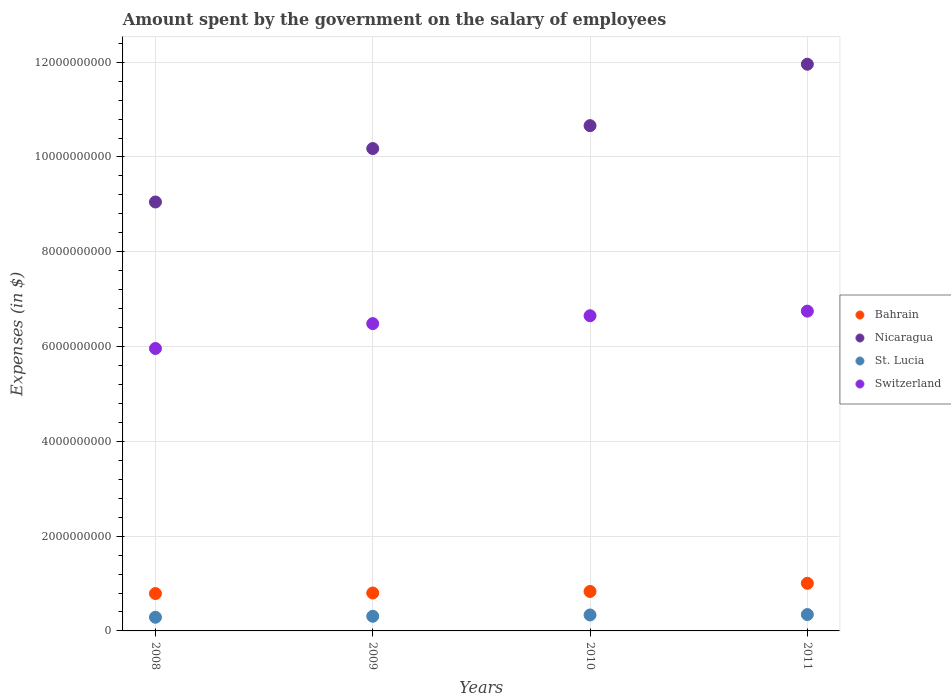How many different coloured dotlines are there?
Your answer should be compact. 4. Is the number of dotlines equal to the number of legend labels?
Offer a terse response. Yes. What is the amount spent on the salary of employees by the government in Bahrain in 2009?
Offer a terse response. 8.00e+08. Across all years, what is the maximum amount spent on the salary of employees by the government in Nicaragua?
Provide a short and direct response. 1.20e+1. Across all years, what is the minimum amount spent on the salary of employees by the government in St. Lucia?
Ensure brevity in your answer.  2.88e+08. In which year was the amount spent on the salary of employees by the government in Switzerland maximum?
Provide a short and direct response. 2011. What is the total amount spent on the salary of employees by the government in Nicaragua in the graph?
Give a very brief answer. 4.18e+1. What is the difference between the amount spent on the salary of employees by the government in Bahrain in 2010 and that in 2011?
Your answer should be compact. -1.73e+08. What is the difference between the amount spent on the salary of employees by the government in St. Lucia in 2011 and the amount spent on the salary of employees by the government in Switzerland in 2008?
Ensure brevity in your answer.  -5.61e+09. What is the average amount spent on the salary of employees by the government in St. Lucia per year?
Offer a terse response. 3.20e+08. In the year 2008, what is the difference between the amount spent on the salary of employees by the government in St. Lucia and amount spent on the salary of employees by the government in Bahrain?
Provide a succinct answer. -5.00e+08. In how many years, is the amount spent on the salary of employees by the government in Nicaragua greater than 9600000000 $?
Keep it short and to the point. 3. What is the ratio of the amount spent on the salary of employees by the government in Switzerland in 2008 to that in 2010?
Your answer should be compact. 0.9. What is the difference between the highest and the second highest amount spent on the salary of employees by the government in Nicaragua?
Offer a very short reply. 1.30e+09. What is the difference between the highest and the lowest amount spent on the salary of employees by the government in Nicaragua?
Give a very brief answer. 2.91e+09. Is the amount spent on the salary of employees by the government in Switzerland strictly greater than the amount spent on the salary of employees by the government in St. Lucia over the years?
Ensure brevity in your answer.  Yes. Is the amount spent on the salary of employees by the government in Bahrain strictly less than the amount spent on the salary of employees by the government in Nicaragua over the years?
Offer a very short reply. Yes. Does the graph contain grids?
Offer a very short reply. Yes. What is the title of the graph?
Provide a short and direct response. Amount spent by the government on the salary of employees. Does "Caribbean small states" appear as one of the legend labels in the graph?
Your response must be concise. No. What is the label or title of the X-axis?
Provide a short and direct response. Years. What is the label or title of the Y-axis?
Your answer should be very brief. Expenses (in $). What is the Expenses (in $) in Bahrain in 2008?
Your response must be concise. 7.89e+08. What is the Expenses (in $) of Nicaragua in 2008?
Offer a very short reply. 9.05e+09. What is the Expenses (in $) of St. Lucia in 2008?
Provide a succinct answer. 2.88e+08. What is the Expenses (in $) in Switzerland in 2008?
Offer a terse response. 5.96e+09. What is the Expenses (in $) of Bahrain in 2009?
Keep it short and to the point. 8.00e+08. What is the Expenses (in $) of Nicaragua in 2009?
Provide a succinct answer. 1.02e+1. What is the Expenses (in $) in St. Lucia in 2009?
Ensure brevity in your answer.  3.09e+08. What is the Expenses (in $) of Switzerland in 2009?
Provide a succinct answer. 6.48e+09. What is the Expenses (in $) of Bahrain in 2010?
Give a very brief answer. 8.32e+08. What is the Expenses (in $) in Nicaragua in 2010?
Offer a terse response. 1.07e+1. What is the Expenses (in $) of St. Lucia in 2010?
Offer a very short reply. 3.37e+08. What is the Expenses (in $) of Switzerland in 2010?
Your answer should be very brief. 6.65e+09. What is the Expenses (in $) in Bahrain in 2011?
Keep it short and to the point. 1.00e+09. What is the Expenses (in $) in Nicaragua in 2011?
Provide a short and direct response. 1.20e+1. What is the Expenses (in $) in St. Lucia in 2011?
Offer a very short reply. 3.45e+08. What is the Expenses (in $) in Switzerland in 2011?
Your answer should be compact. 6.75e+09. Across all years, what is the maximum Expenses (in $) in Bahrain?
Your response must be concise. 1.00e+09. Across all years, what is the maximum Expenses (in $) in Nicaragua?
Give a very brief answer. 1.20e+1. Across all years, what is the maximum Expenses (in $) of St. Lucia?
Give a very brief answer. 3.45e+08. Across all years, what is the maximum Expenses (in $) in Switzerland?
Offer a very short reply. 6.75e+09. Across all years, what is the minimum Expenses (in $) in Bahrain?
Offer a terse response. 7.89e+08. Across all years, what is the minimum Expenses (in $) in Nicaragua?
Your response must be concise. 9.05e+09. Across all years, what is the minimum Expenses (in $) in St. Lucia?
Provide a short and direct response. 2.88e+08. Across all years, what is the minimum Expenses (in $) of Switzerland?
Ensure brevity in your answer.  5.96e+09. What is the total Expenses (in $) in Bahrain in the graph?
Your response must be concise. 3.43e+09. What is the total Expenses (in $) in Nicaragua in the graph?
Provide a short and direct response. 4.18e+1. What is the total Expenses (in $) in St. Lucia in the graph?
Your answer should be compact. 1.28e+09. What is the total Expenses (in $) of Switzerland in the graph?
Offer a terse response. 2.58e+1. What is the difference between the Expenses (in $) in Bahrain in 2008 and that in 2009?
Provide a succinct answer. -1.12e+07. What is the difference between the Expenses (in $) of Nicaragua in 2008 and that in 2009?
Your answer should be compact. -1.13e+09. What is the difference between the Expenses (in $) in St. Lucia in 2008 and that in 2009?
Give a very brief answer. -2.07e+07. What is the difference between the Expenses (in $) in Switzerland in 2008 and that in 2009?
Your answer should be very brief. -5.24e+08. What is the difference between the Expenses (in $) in Bahrain in 2008 and that in 2010?
Provide a short and direct response. -4.38e+07. What is the difference between the Expenses (in $) in Nicaragua in 2008 and that in 2010?
Offer a terse response. -1.61e+09. What is the difference between the Expenses (in $) of St. Lucia in 2008 and that in 2010?
Your answer should be very brief. -4.83e+07. What is the difference between the Expenses (in $) of Switzerland in 2008 and that in 2010?
Ensure brevity in your answer.  -6.91e+08. What is the difference between the Expenses (in $) of Bahrain in 2008 and that in 2011?
Make the answer very short. -2.16e+08. What is the difference between the Expenses (in $) in Nicaragua in 2008 and that in 2011?
Make the answer very short. -2.91e+09. What is the difference between the Expenses (in $) of St. Lucia in 2008 and that in 2011?
Your answer should be very brief. -5.71e+07. What is the difference between the Expenses (in $) of Switzerland in 2008 and that in 2011?
Make the answer very short. -7.88e+08. What is the difference between the Expenses (in $) in Bahrain in 2009 and that in 2010?
Your answer should be very brief. -3.25e+07. What is the difference between the Expenses (in $) of Nicaragua in 2009 and that in 2010?
Offer a very short reply. -4.83e+08. What is the difference between the Expenses (in $) in St. Lucia in 2009 and that in 2010?
Keep it short and to the point. -2.76e+07. What is the difference between the Expenses (in $) of Switzerland in 2009 and that in 2010?
Your response must be concise. -1.66e+08. What is the difference between the Expenses (in $) in Bahrain in 2009 and that in 2011?
Your answer should be very brief. -2.05e+08. What is the difference between the Expenses (in $) of Nicaragua in 2009 and that in 2011?
Ensure brevity in your answer.  -1.78e+09. What is the difference between the Expenses (in $) in St. Lucia in 2009 and that in 2011?
Make the answer very short. -3.64e+07. What is the difference between the Expenses (in $) in Switzerland in 2009 and that in 2011?
Ensure brevity in your answer.  -2.64e+08. What is the difference between the Expenses (in $) of Bahrain in 2010 and that in 2011?
Provide a short and direct response. -1.73e+08. What is the difference between the Expenses (in $) in Nicaragua in 2010 and that in 2011?
Keep it short and to the point. -1.30e+09. What is the difference between the Expenses (in $) in St. Lucia in 2010 and that in 2011?
Your answer should be very brief. -8.80e+06. What is the difference between the Expenses (in $) in Switzerland in 2010 and that in 2011?
Your answer should be compact. -9.73e+07. What is the difference between the Expenses (in $) in Bahrain in 2008 and the Expenses (in $) in Nicaragua in 2009?
Provide a short and direct response. -9.39e+09. What is the difference between the Expenses (in $) in Bahrain in 2008 and the Expenses (in $) in St. Lucia in 2009?
Provide a succinct answer. 4.80e+08. What is the difference between the Expenses (in $) in Bahrain in 2008 and the Expenses (in $) in Switzerland in 2009?
Ensure brevity in your answer.  -5.70e+09. What is the difference between the Expenses (in $) of Nicaragua in 2008 and the Expenses (in $) of St. Lucia in 2009?
Ensure brevity in your answer.  8.74e+09. What is the difference between the Expenses (in $) in Nicaragua in 2008 and the Expenses (in $) in Switzerland in 2009?
Your response must be concise. 2.57e+09. What is the difference between the Expenses (in $) of St. Lucia in 2008 and the Expenses (in $) of Switzerland in 2009?
Provide a short and direct response. -6.20e+09. What is the difference between the Expenses (in $) of Bahrain in 2008 and the Expenses (in $) of Nicaragua in 2010?
Offer a terse response. -9.87e+09. What is the difference between the Expenses (in $) of Bahrain in 2008 and the Expenses (in $) of St. Lucia in 2010?
Offer a very short reply. 4.52e+08. What is the difference between the Expenses (in $) of Bahrain in 2008 and the Expenses (in $) of Switzerland in 2010?
Provide a succinct answer. -5.86e+09. What is the difference between the Expenses (in $) in Nicaragua in 2008 and the Expenses (in $) in St. Lucia in 2010?
Make the answer very short. 8.71e+09. What is the difference between the Expenses (in $) of Nicaragua in 2008 and the Expenses (in $) of Switzerland in 2010?
Your answer should be compact. 2.40e+09. What is the difference between the Expenses (in $) in St. Lucia in 2008 and the Expenses (in $) in Switzerland in 2010?
Keep it short and to the point. -6.36e+09. What is the difference between the Expenses (in $) of Bahrain in 2008 and the Expenses (in $) of Nicaragua in 2011?
Offer a very short reply. -1.12e+1. What is the difference between the Expenses (in $) in Bahrain in 2008 and the Expenses (in $) in St. Lucia in 2011?
Provide a short and direct response. 4.43e+08. What is the difference between the Expenses (in $) in Bahrain in 2008 and the Expenses (in $) in Switzerland in 2011?
Your answer should be compact. -5.96e+09. What is the difference between the Expenses (in $) in Nicaragua in 2008 and the Expenses (in $) in St. Lucia in 2011?
Offer a terse response. 8.71e+09. What is the difference between the Expenses (in $) of Nicaragua in 2008 and the Expenses (in $) of Switzerland in 2011?
Provide a succinct answer. 2.30e+09. What is the difference between the Expenses (in $) of St. Lucia in 2008 and the Expenses (in $) of Switzerland in 2011?
Offer a very short reply. -6.46e+09. What is the difference between the Expenses (in $) of Bahrain in 2009 and the Expenses (in $) of Nicaragua in 2010?
Ensure brevity in your answer.  -9.86e+09. What is the difference between the Expenses (in $) of Bahrain in 2009 and the Expenses (in $) of St. Lucia in 2010?
Make the answer very short. 4.63e+08. What is the difference between the Expenses (in $) in Bahrain in 2009 and the Expenses (in $) in Switzerland in 2010?
Your response must be concise. -5.85e+09. What is the difference between the Expenses (in $) of Nicaragua in 2009 and the Expenses (in $) of St. Lucia in 2010?
Keep it short and to the point. 9.84e+09. What is the difference between the Expenses (in $) in Nicaragua in 2009 and the Expenses (in $) in Switzerland in 2010?
Provide a short and direct response. 3.53e+09. What is the difference between the Expenses (in $) of St. Lucia in 2009 and the Expenses (in $) of Switzerland in 2010?
Your answer should be compact. -6.34e+09. What is the difference between the Expenses (in $) of Bahrain in 2009 and the Expenses (in $) of Nicaragua in 2011?
Your answer should be very brief. -1.12e+1. What is the difference between the Expenses (in $) of Bahrain in 2009 and the Expenses (in $) of St. Lucia in 2011?
Offer a very short reply. 4.54e+08. What is the difference between the Expenses (in $) in Bahrain in 2009 and the Expenses (in $) in Switzerland in 2011?
Offer a very short reply. -5.95e+09. What is the difference between the Expenses (in $) in Nicaragua in 2009 and the Expenses (in $) in St. Lucia in 2011?
Your response must be concise. 9.83e+09. What is the difference between the Expenses (in $) in Nicaragua in 2009 and the Expenses (in $) in Switzerland in 2011?
Offer a terse response. 3.43e+09. What is the difference between the Expenses (in $) of St. Lucia in 2009 and the Expenses (in $) of Switzerland in 2011?
Offer a very short reply. -6.44e+09. What is the difference between the Expenses (in $) of Bahrain in 2010 and the Expenses (in $) of Nicaragua in 2011?
Ensure brevity in your answer.  -1.11e+1. What is the difference between the Expenses (in $) of Bahrain in 2010 and the Expenses (in $) of St. Lucia in 2011?
Your answer should be compact. 4.87e+08. What is the difference between the Expenses (in $) of Bahrain in 2010 and the Expenses (in $) of Switzerland in 2011?
Your answer should be very brief. -5.92e+09. What is the difference between the Expenses (in $) of Nicaragua in 2010 and the Expenses (in $) of St. Lucia in 2011?
Make the answer very short. 1.03e+1. What is the difference between the Expenses (in $) of Nicaragua in 2010 and the Expenses (in $) of Switzerland in 2011?
Your answer should be very brief. 3.91e+09. What is the difference between the Expenses (in $) of St. Lucia in 2010 and the Expenses (in $) of Switzerland in 2011?
Provide a short and direct response. -6.41e+09. What is the average Expenses (in $) of Bahrain per year?
Give a very brief answer. 8.56e+08. What is the average Expenses (in $) of Nicaragua per year?
Your response must be concise. 1.05e+1. What is the average Expenses (in $) in St. Lucia per year?
Offer a terse response. 3.20e+08. What is the average Expenses (in $) of Switzerland per year?
Make the answer very short. 6.46e+09. In the year 2008, what is the difference between the Expenses (in $) of Bahrain and Expenses (in $) of Nicaragua?
Give a very brief answer. -8.26e+09. In the year 2008, what is the difference between the Expenses (in $) in Bahrain and Expenses (in $) in St. Lucia?
Your answer should be very brief. 5.00e+08. In the year 2008, what is the difference between the Expenses (in $) in Bahrain and Expenses (in $) in Switzerland?
Your answer should be very brief. -5.17e+09. In the year 2008, what is the difference between the Expenses (in $) of Nicaragua and Expenses (in $) of St. Lucia?
Give a very brief answer. 8.76e+09. In the year 2008, what is the difference between the Expenses (in $) in Nicaragua and Expenses (in $) in Switzerland?
Make the answer very short. 3.09e+09. In the year 2008, what is the difference between the Expenses (in $) in St. Lucia and Expenses (in $) in Switzerland?
Provide a succinct answer. -5.67e+09. In the year 2009, what is the difference between the Expenses (in $) of Bahrain and Expenses (in $) of Nicaragua?
Your answer should be very brief. -9.38e+09. In the year 2009, what is the difference between the Expenses (in $) in Bahrain and Expenses (in $) in St. Lucia?
Offer a terse response. 4.91e+08. In the year 2009, what is the difference between the Expenses (in $) in Bahrain and Expenses (in $) in Switzerland?
Provide a short and direct response. -5.68e+09. In the year 2009, what is the difference between the Expenses (in $) in Nicaragua and Expenses (in $) in St. Lucia?
Ensure brevity in your answer.  9.87e+09. In the year 2009, what is the difference between the Expenses (in $) in Nicaragua and Expenses (in $) in Switzerland?
Ensure brevity in your answer.  3.69e+09. In the year 2009, what is the difference between the Expenses (in $) in St. Lucia and Expenses (in $) in Switzerland?
Your answer should be very brief. -6.17e+09. In the year 2010, what is the difference between the Expenses (in $) in Bahrain and Expenses (in $) in Nicaragua?
Keep it short and to the point. -9.83e+09. In the year 2010, what is the difference between the Expenses (in $) of Bahrain and Expenses (in $) of St. Lucia?
Your answer should be compact. 4.96e+08. In the year 2010, what is the difference between the Expenses (in $) in Bahrain and Expenses (in $) in Switzerland?
Your answer should be compact. -5.82e+09. In the year 2010, what is the difference between the Expenses (in $) in Nicaragua and Expenses (in $) in St. Lucia?
Offer a very short reply. 1.03e+1. In the year 2010, what is the difference between the Expenses (in $) of Nicaragua and Expenses (in $) of Switzerland?
Offer a terse response. 4.01e+09. In the year 2010, what is the difference between the Expenses (in $) in St. Lucia and Expenses (in $) in Switzerland?
Offer a very short reply. -6.31e+09. In the year 2011, what is the difference between the Expenses (in $) of Bahrain and Expenses (in $) of Nicaragua?
Your answer should be compact. -1.10e+1. In the year 2011, what is the difference between the Expenses (in $) of Bahrain and Expenses (in $) of St. Lucia?
Provide a succinct answer. 6.60e+08. In the year 2011, what is the difference between the Expenses (in $) of Bahrain and Expenses (in $) of Switzerland?
Provide a short and direct response. -5.74e+09. In the year 2011, what is the difference between the Expenses (in $) in Nicaragua and Expenses (in $) in St. Lucia?
Your response must be concise. 1.16e+1. In the year 2011, what is the difference between the Expenses (in $) of Nicaragua and Expenses (in $) of Switzerland?
Your response must be concise. 5.21e+09. In the year 2011, what is the difference between the Expenses (in $) in St. Lucia and Expenses (in $) in Switzerland?
Provide a succinct answer. -6.40e+09. What is the ratio of the Expenses (in $) in Nicaragua in 2008 to that in 2009?
Your answer should be compact. 0.89. What is the ratio of the Expenses (in $) in St. Lucia in 2008 to that in 2009?
Make the answer very short. 0.93. What is the ratio of the Expenses (in $) of Switzerland in 2008 to that in 2009?
Provide a short and direct response. 0.92. What is the ratio of the Expenses (in $) in Bahrain in 2008 to that in 2010?
Your answer should be compact. 0.95. What is the ratio of the Expenses (in $) in Nicaragua in 2008 to that in 2010?
Offer a terse response. 0.85. What is the ratio of the Expenses (in $) in St. Lucia in 2008 to that in 2010?
Your answer should be compact. 0.86. What is the ratio of the Expenses (in $) in Switzerland in 2008 to that in 2010?
Give a very brief answer. 0.9. What is the ratio of the Expenses (in $) of Bahrain in 2008 to that in 2011?
Your answer should be very brief. 0.78. What is the ratio of the Expenses (in $) in Nicaragua in 2008 to that in 2011?
Ensure brevity in your answer.  0.76. What is the ratio of the Expenses (in $) in St. Lucia in 2008 to that in 2011?
Provide a succinct answer. 0.83. What is the ratio of the Expenses (in $) in Switzerland in 2008 to that in 2011?
Provide a short and direct response. 0.88. What is the ratio of the Expenses (in $) in Bahrain in 2009 to that in 2010?
Give a very brief answer. 0.96. What is the ratio of the Expenses (in $) in Nicaragua in 2009 to that in 2010?
Offer a very short reply. 0.95. What is the ratio of the Expenses (in $) in St. Lucia in 2009 to that in 2010?
Make the answer very short. 0.92. What is the ratio of the Expenses (in $) in Switzerland in 2009 to that in 2010?
Provide a short and direct response. 0.97. What is the ratio of the Expenses (in $) in Bahrain in 2009 to that in 2011?
Provide a short and direct response. 0.8. What is the ratio of the Expenses (in $) of Nicaragua in 2009 to that in 2011?
Offer a very short reply. 0.85. What is the ratio of the Expenses (in $) in St. Lucia in 2009 to that in 2011?
Offer a terse response. 0.89. What is the ratio of the Expenses (in $) of Switzerland in 2009 to that in 2011?
Provide a short and direct response. 0.96. What is the ratio of the Expenses (in $) of Bahrain in 2010 to that in 2011?
Offer a terse response. 0.83. What is the ratio of the Expenses (in $) in Nicaragua in 2010 to that in 2011?
Keep it short and to the point. 0.89. What is the ratio of the Expenses (in $) in St. Lucia in 2010 to that in 2011?
Your answer should be very brief. 0.97. What is the ratio of the Expenses (in $) of Switzerland in 2010 to that in 2011?
Offer a terse response. 0.99. What is the difference between the highest and the second highest Expenses (in $) in Bahrain?
Give a very brief answer. 1.73e+08. What is the difference between the highest and the second highest Expenses (in $) of Nicaragua?
Ensure brevity in your answer.  1.30e+09. What is the difference between the highest and the second highest Expenses (in $) in St. Lucia?
Your answer should be compact. 8.80e+06. What is the difference between the highest and the second highest Expenses (in $) of Switzerland?
Make the answer very short. 9.73e+07. What is the difference between the highest and the lowest Expenses (in $) of Bahrain?
Ensure brevity in your answer.  2.16e+08. What is the difference between the highest and the lowest Expenses (in $) of Nicaragua?
Give a very brief answer. 2.91e+09. What is the difference between the highest and the lowest Expenses (in $) of St. Lucia?
Offer a terse response. 5.71e+07. What is the difference between the highest and the lowest Expenses (in $) of Switzerland?
Make the answer very short. 7.88e+08. 